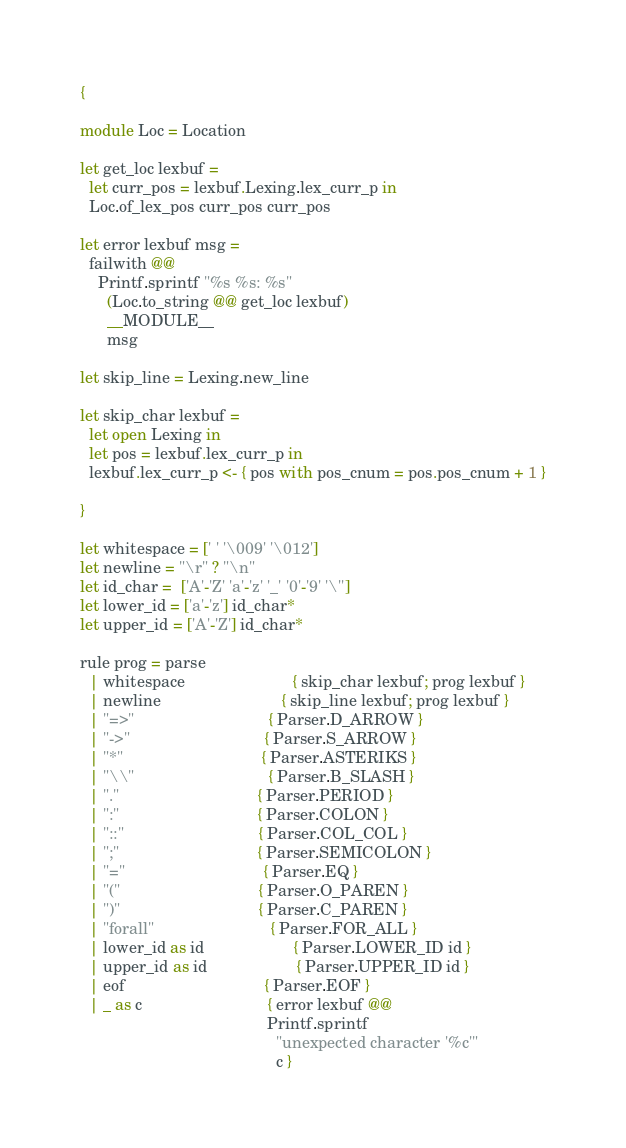Convert code to text. <code><loc_0><loc_0><loc_500><loc_500><_OCaml_>{

module Loc = Location

let get_loc lexbuf =
  let curr_pos = lexbuf.Lexing.lex_curr_p in
  Loc.of_lex_pos curr_pos curr_pos

let error lexbuf msg =
  failwith @@
    Printf.sprintf "%s %s: %s"
      (Loc.to_string @@ get_loc lexbuf)
      __MODULE__
      msg

let skip_line = Lexing.new_line

let skip_char lexbuf =
  let open Lexing in
  let pos = lexbuf.lex_curr_p in
  lexbuf.lex_curr_p <- { pos with pos_cnum = pos.pos_cnum + 1 }

}

let whitespace = [' ' '\009' '\012']
let newline = "\r" ? "\n"
let id_char =  ['A'-'Z' 'a'-'z' '_' '0'-'9' '\'']
let lower_id = ['a'-'z'] id_char*
let upper_id = ['A'-'Z'] id_char*

rule prog = parse
  | whitespace                        { skip_char lexbuf; prog lexbuf }
  | newline                           { skip_line lexbuf; prog lexbuf }
  | "=>"                              { Parser.D_ARROW }
  | "->"                              { Parser.S_ARROW }
  | "*"                               { Parser.ASTERIKS }
  | "\\"                              { Parser.B_SLASH }
  | "."                               { Parser.PERIOD }
  | ":"                               { Parser.COLON }
  | "::"                              { Parser.COL_COL }
  | ";"                               { Parser.SEMICOLON }
  | "="                               { Parser.EQ }
  | "("                               { Parser.O_PAREN }
  | ")"                               { Parser.C_PAREN }
  | "forall"                          { Parser.FOR_ALL }
  | lower_id as id                    { Parser.LOWER_ID id }
  | upper_id as id                    { Parser.UPPER_ID id }
  | eof                               { Parser.EOF }
  | _ as c                            { error lexbuf @@
                                          Printf.sprintf
                                            "unexpected character '%c'"
                                            c }
</code> 